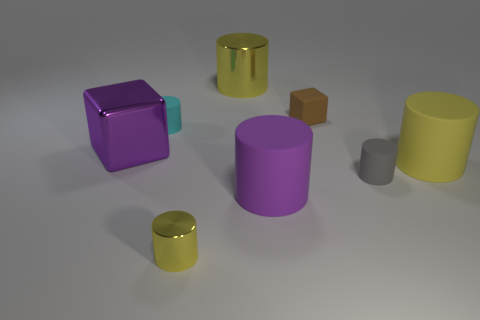How many yellow cylinders must be subtracted to get 1 yellow cylinders? 2 Subtract all gray blocks. How many yellow cylinders are left? 3 Subtract all purple cylinders. How many cylinders are left? 5 Subtract 1 cylinders. How many cylinders are left? 5 Subtract all gray cylinders. How many cylinders are left? 5 Subtract all gray cylinders. Subtract all brown balls. How many cylinders are left? 5 Add 2 cyan matte cylinders. How many objects exist? 10 Subtract all blocks. How many objects are left? 6 Add 2 cyan things. How many cyan things exist? 3 Subtract 0 green cubes. How many objects are left? 8 